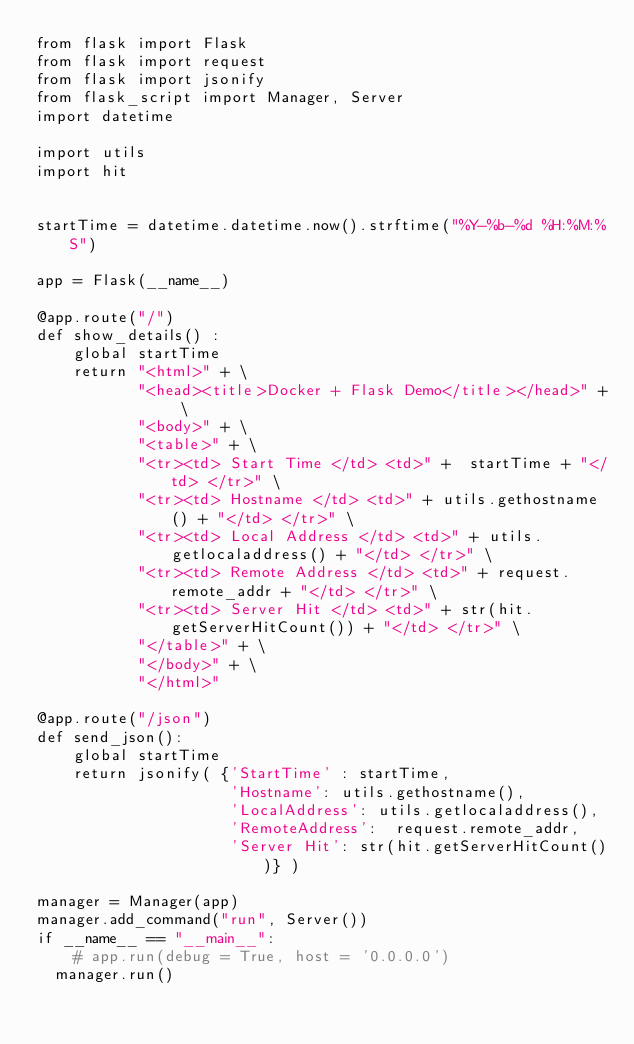<code> <loc_0><loc_0><loc_500><loc_500><_Python_>from flask import Flask
from flask import request
from flask import jsonify
from flask_script import Manager, Server
import datetime

import utils
import hit


startTime = datetime.datetime.now().strftime("%Y-%b-%d %H:%M:%S")

app = Flask(__name__)

@app.route("/")
def show_details() :
    global startTime
    return "<html>" + \
           "<head><title>Docker + Flask Demo</title></head>" + \
           "<body>" + \
           "<table>" + \
           "<tr><td> Start Time </td> <td>" +  startTime + "</td> </tr>" \
           "<tr><td> Hostname </td> <td>" + utils.gethostname() + "</td> </tr>" \
           "<tr><td> Local Address </td> <td>" + utils.getlocaladdress() + "</td> </tr>" \
           "<tr><td> Remote Address </td> <td>" + request.remote_addr + "</td> </tr>" \
           "<tr><td> Server Hit </td> <td>" + str(hit.getServerHitCount()) + "</td> </tr>" \
           "</table>" + \
           "</body>" + \
           "</html>"

@app.route("/json")
def send_json():
    global startTime
    return jsonify( {'StartTime' : startTime,
                     'Hostname': utils.gethostname(),
                     'LocalAddress': utils.getlocaladdress(),
                     'RemoteAddress':  request.remote_addr,
                     'Server Hit': str(hit.getServerHitCount())} )

manager = Manager(app)
manager.add_command("run", Server())
if __name__ == "__main__":
    # app.run(debug = True, host = '0.0.0.0')
	manager.run()
</code> 